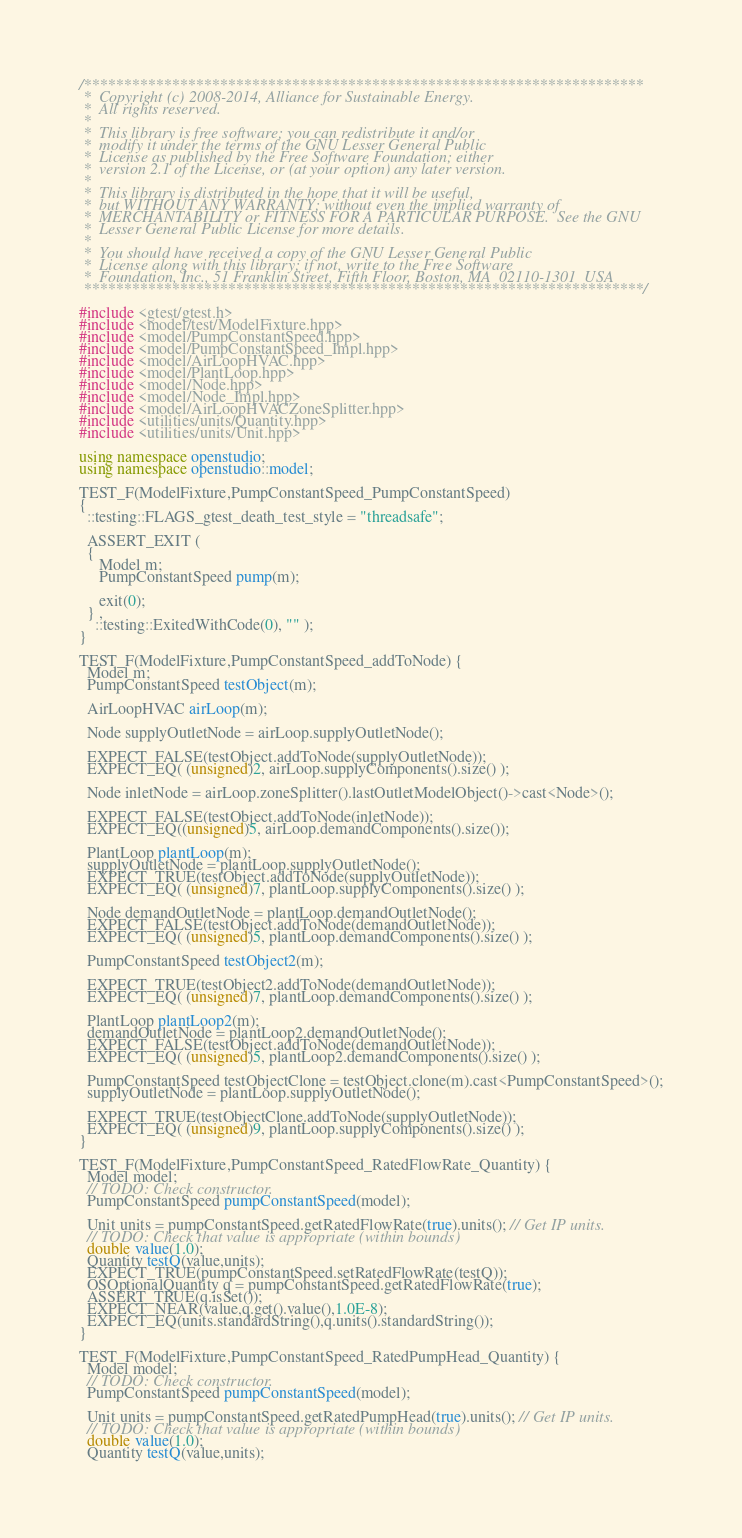<code> <loc_0><loc_0><loc_500><loc_500><_C++_>/**********************************************************************
 *  Copyright (c) 2008-2014, Alliance for Sustainable Energy.
 *  All rights reserved.
 *
 *  This library is free software; you can redistribute it and/or
 *  modify it under the terms of the GNU Lesser General Public
 *  License as published by the Free Software Foundation; either
 *  version 2.1 of the License, or (at your option) any later version.
 *
 *  This library is distributed in the hope that it will be useful,
 *  but WITHOUT ANY WARRANTY; without even the implied warranty of
 *  MERCHANTABILITY or FITNESS FOR A PARTICULAR PURPOSE.  See the GNU
 *  Lesser General Public License for more details.
 *
 *  You should have received a copy of the GNU Lesser General Public
 *  License along with this library; if not, write to the Free Software
 *  Foundation, Inc., 51 Franklin Street, Fifth Floor, Boston, MA  02110-1301  USA
 **********************************************************************/

#include <gtest/gtest.h>
#include <model/test/ModelFixture.hpp>
#include <model/PumpConstantSpeed.hpp>
#include <model/PumpConstantSpeed_Impl.hpp>
#include <model/AirLoopHVAC.hpp>
#include <model/PlantLoop.hpp>
#include <model/Node.hpp>
#include <model/Node_Impl.hpp>
#include <model/AirLoopHVACZoneSplitter.hpp>
#include <utilities/units/Quantity.hpp>
#include <utilities/units/Unit.hpp>

using namespace openstudio;
using namespace openstudio::model;

TEST_F(ModelFixture,PumpConstantSpeed_PumpConstantSpeed)
{
  ::testing::FLAGS_gtest_death_test_style = "threadsafe";

  ASSERT_EXIT ( 
  {  
     Model m; 
     PumpConstantSpeed pump(m); 

     exit(0); 
  } ,
    ::testing::ExitedWithCode(0), "" );
}

TEST_F(ModelFixture,PumpConstantSpeed_addToNode) {
  Model m;
  PumpConstantSpeed testObject(m);

  AirLoopHVAC airLoop(m);

  Node supplyOutletNode = airLoop.supplyOutletNode();

  EXPECT_FALSE(testObject.addToNode(supplyOutletNode));
  EXPECT_EQ( (unsigned)2, airLoop.supplyComponents().size() );

  Node inletNode = airLoop.zoneSplitter().lastOutletModelObject()->cast<Node>();

  EXPECT_FALSE(testObject.addToNode(inletNode));
  EXPECT_EQ((unsigned)5, airLoop.demandComponents().size());

  PlantLoop plantLoop(m);
  supplyOutletNode = plantLoop.supplyOutletNode();
  EXPECT_TRUE(testObject.addToNode(supplyOutletNode));
  EXPECT_EQ( (unsigned)7, plantLoop.supplyComponents().size() );

  Node demandOutletNode = plantLoop.demandOutletNode();
  EXPECT_FALSE(testObject.addToNode(demandOutletNode));
  EXPECT_EQ( (unsigned)5, plantLoop.demandComponents().size() );

  PumpConstantSpeed testObject2(m);

  EXPECT_TRUE(testObject2.addToNode(demandOutletNode));
  EXPECT_EQ( (unsigned)7, plantLoop.demandComponents().size() );

  PlantLoop plantLoop2(m);
  demandOutletNode = plantLoop2.demandOutletNode();
  EXPECT_FALSE(testObject.addToNode(demandOutletNode));
  EXPECT_EQ( (unsigned)5, plantLoop2.demandComponents().size() );

  PumpConstantSpeed testObjectClone = testObject.clone(m).cast<PumpConstantSpeed>();
  supplyOutletNode = plantLoop.supplyOutletNode();

  EXPECT_TRUE(testObjectClone.addToNode(supplyOutletNode));
  EXPECT_EQ( (unsigned)9, plantLoop.supplyComponents().size() );
}

TEST_F(ModelFixture,PumpConstantSpeed_RatedFlowRate_Quantity) {
  Model model;
  // TODO: Check constructor.
  PumpConstantSpeed pumpConstantSpeed(model);

  Unit units = pumpConstantSpeed.getRatedFlowRate(true).units(); // Get IP units.
  // TODO: Check that value is appropriate (within bounds)
  double value(1.0);
  Quantity testQ(value,units);
  EXPECT_TRUE(pumpConstantSpeed.setRatedFlowRate(testQ));
  OSOptionalQuantity q = pumpConstantSpeed.getRatedFlowRate(true);
  ASSERT_TRUE(q.isSet());
  EXPECT_NEAR(value,q.get().value(),1.0E-8);
  EXPECT_EQ(units.standardString(),q.units().standardString());
}

TEST_F(ModelFixture,PumpConstantSpeed_RatedPumpHead_Quantity) {
  Model model;
  // TODO: Check constructor.
  PumpConstantSpeed pumpConstantSpeed(model);

  Unit units = pumpConstantSpeed.getRatedPumpHead(true).units(); // Get IP units.
  // TODO: Check that value is appropriate (within bounds)
  double value(1.0);
  Quantity testQ(value,units);</code> 